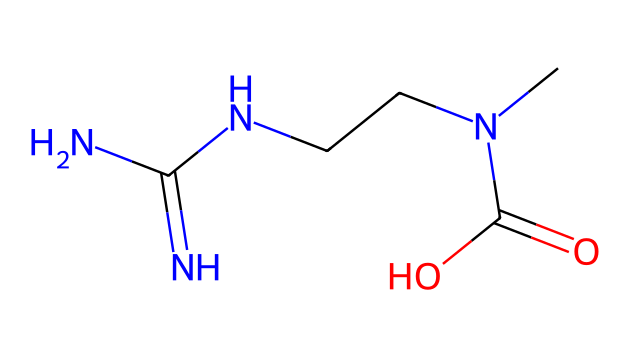What is the molecular formula of this compound? To determine the molecular formula, count the number of each type of atom in the SMILES representation: there are 6 Carbon (C), 13 Hydrogen (H), 4 Nitrogen (N), and 2 Oxygen (O) atoms. Combining these counts gives the formula C6H13N4O2.
Answer: C6H13N4O2 How many nitrogen atoms are present in this compound? The visual representation (SMILES) shows several nitrogen atoms; by counting them, we find there are 4 nitrogen (N) atoms present in the structure.
Answer: 4 What is the functional group present in this compound? The SMILES shows a carboxylic acid group (C(=O)O) as a prominent feature of the molecule, indicating the presence of this specific functional group.
Answer: carboxylic acid Does this compound have any chiral centers? Analyzing the structure, we find carbon atoms that are attached to four different substituents, indicating chiral centers; hence, yes, there are potential chiral centers in this compound.
Answer: yes What kind of biological role does this compound play in the body? The structure suggests that this compound is creatine, which is known to play a role in energy metabolism in muscle tissues by helping recycle ATP.
Answer: energy metabolism What type of bond connects the carbon and nitrogen atoms in this compound? In the SMILES representation, the bond between carbon and nitrogen is a single bond, as indicated by the absence of double or triple bond notations between these atoms.
Answer: single bond 